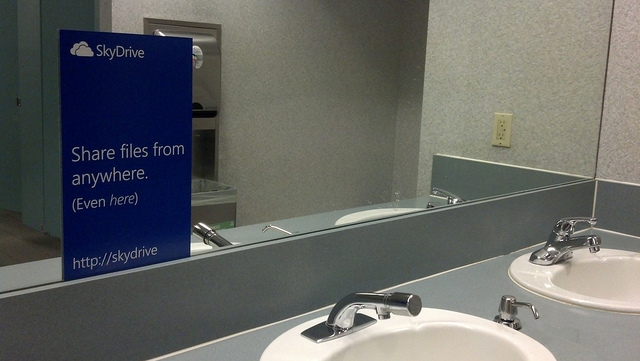Identify and read out the text in this image. files SkyDrive Share anywhere http://skydrive here Even 